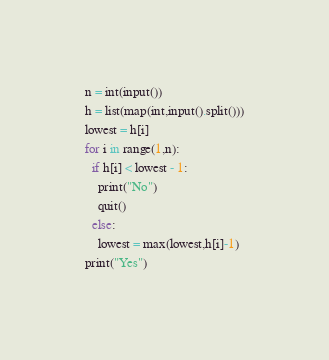<code> <loc_0><loc_0><loc_500><loc_500><_Python_>n = int(input())
h = list(map(int,input().split()))
lowest = h[i]
for i in range(1,n):
  if h[i] < lowest - 1:
    print("No")
    quit()
  else:
    lowest = max(lowest,h[i]-1)
print("Yes")</code> 